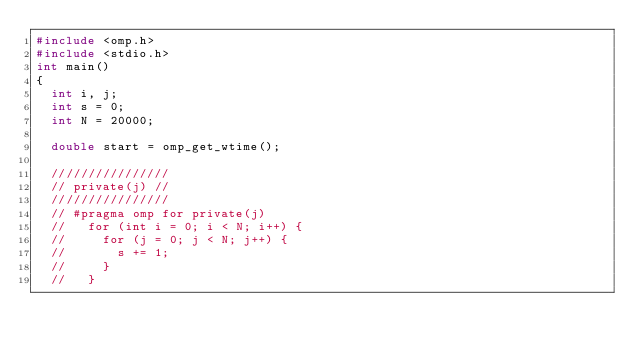<code> <loc_0><loc_0><loc_500><loc_500><_C_>#include <omp.h>
#include <stdio.h>
int main()
{
  int i, j;
  int s = 0;
  int N = 20000;

  double start = omp_get_wtime();

  ////////////////
  // private(j) //
  ////////////////
  // #pragma omp for private(j)
  //   for (int i = 0; i < N; i++) {
  //     for (j = 0; j < N; j++) {
  //       s += 1;
  //     }
  //   }</code> 